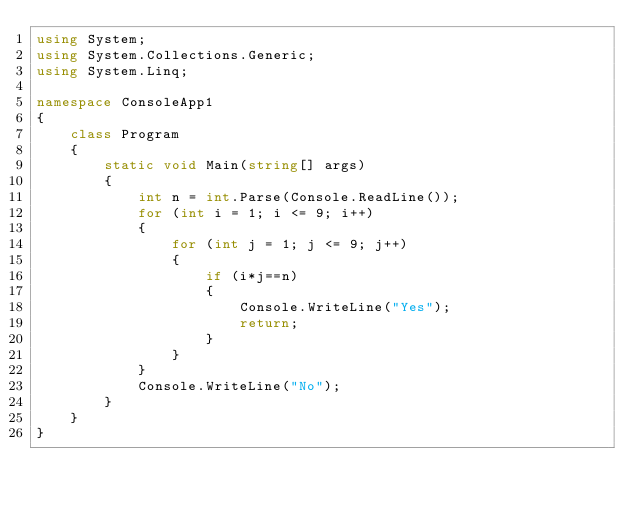<code> <loc_0><loc_0><loc_500><loc_500><_C#_>using System;
using System.Collections.Generic;
using System.Linq;

namespace ConsoleApp1
{
    class Program
    {
        static void Main(string[] args)
        {
            int n = int.Parse(Console.ReadLine());
            for (int i = 1; i <= 9; i++)
            {
                for (int j = 1; j <= 9; j++)
                {
                    if (i*j==n)
                    {
                        Console.WriteLine("Yes");
                        return;
                    }
                }
            }
            Console.WriteLine("No");
        }
    }
}
</code> 